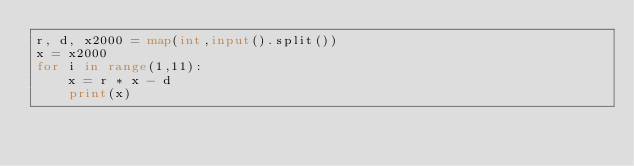Convert code to text. <code><loc_0><loc_0><loc_500><loc_500><_Python_>r, d, x2000 = map(int,input().split())
x = x2000
for i in range(1,11):
    x = r * x - d
    print(x)</code> 